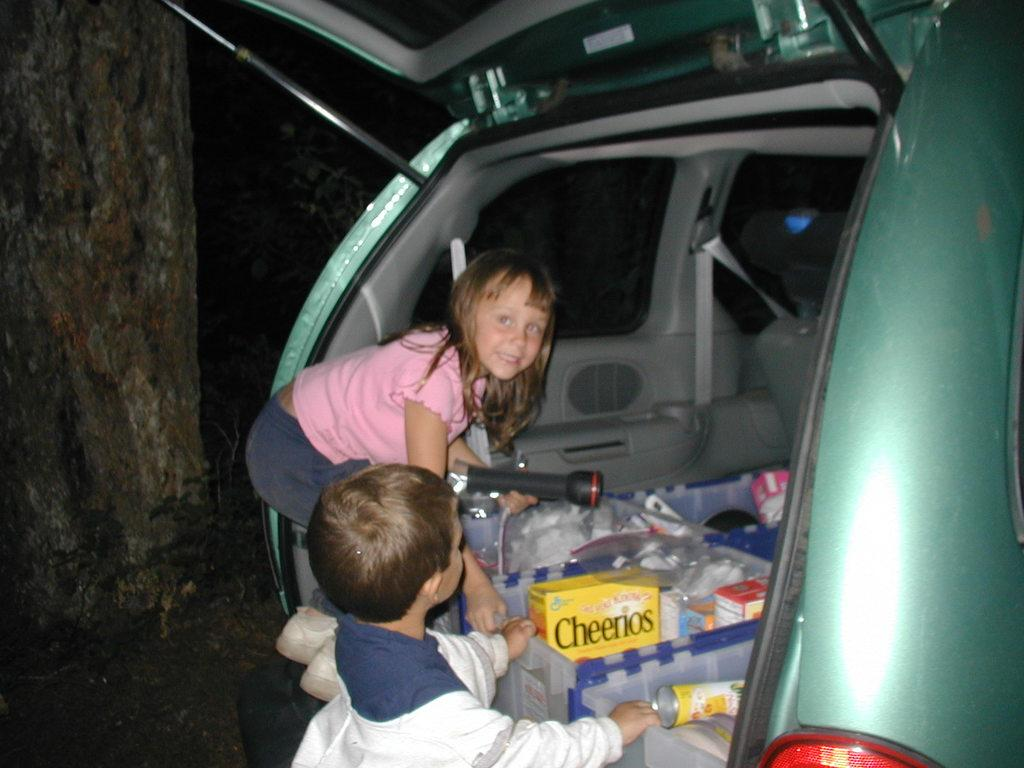How many children are present in the image? There are two children in the image. What else can be seen in the image besides the children? There is a car in the image. What is inside the car? The car contains containers. What type of bells can be heard ringing in the image? There are no bells present in the image, and therefore no sound can be heard. 